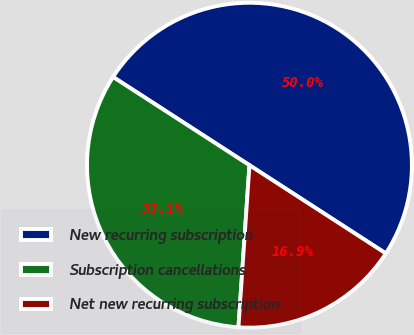<chart> <loc_0><loc_0><loc_500><loc_500><pie_chart><fcel>New recurring subscription<fcel>Subscription cancellations<fcel>Net new recurring subscription<nl><fcel>50.0%<fcel>33.06%<fcel>16.94%<nl></chart> 